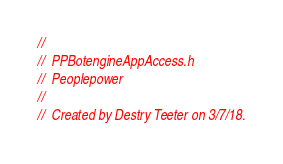<code> <loc_0><loc_0><loc_500><loc_500><_C_>//
//  PPBotengineAppAccess.h
//  Peoplepower
//
//  Created by Destry Teeter on 3/7/18.</code> 